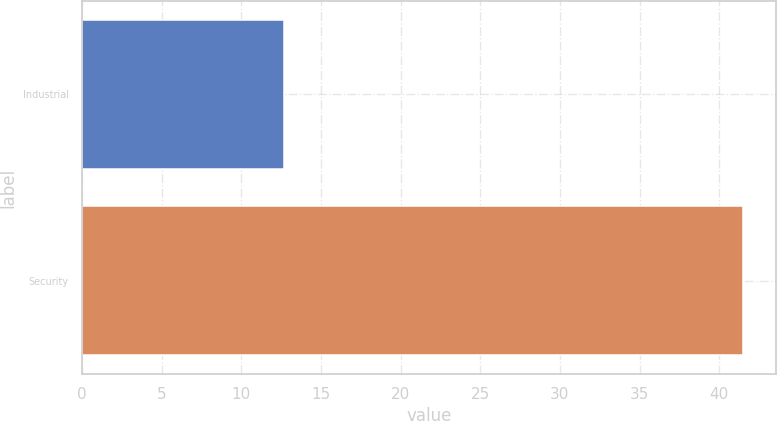Convert chart. <chart><loc_0><loc_0><loc_500><loc_500><bar_chart><fcel>Industrial<fcel>Security<nl><fcel>12.7<fcel>41.5<nl></chart> 